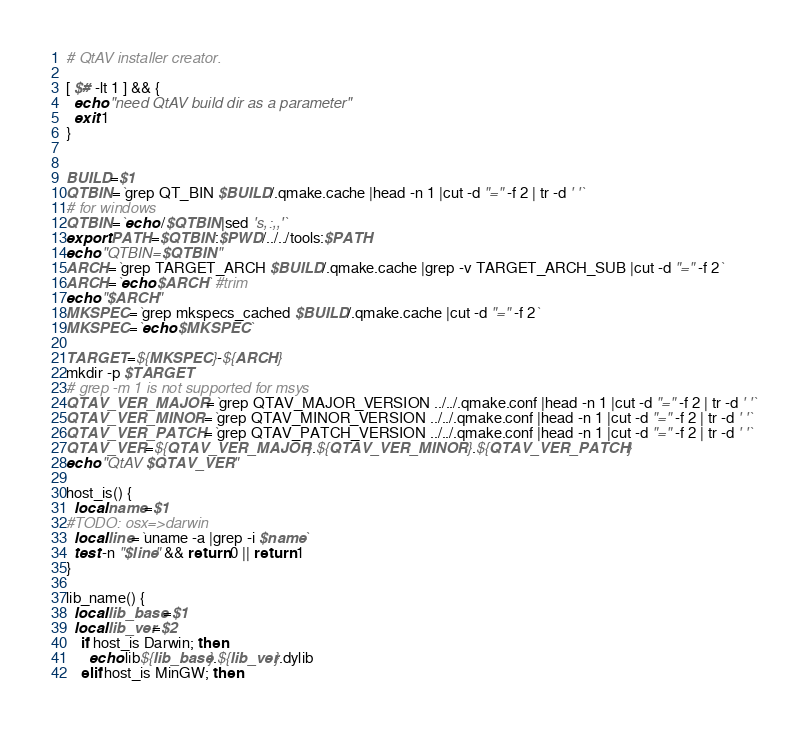Convert code to text. <code><loc_0><loc_0><loc_500><loc_500><_Bash_># QtAV installer creator.

[ $# -lt 1 ] && {
  echo "need QtAV build dir as a parameter"
  exit 1
}


BUILD=$1
QTBIN=`grep QT_BIN $BUILD/.qmake.cache |head -n 1 |cut -d "=" -f 2 | tr -d ' '`
# for windows
QTBIN=`echo /$QTBIN|sed 's,:,,'`
export PATH=$QTBIN:$PWD/../../tools:$PATH
echo "QTBIN=$QTBIN"
ARCH=`grep TARGET_ARCH $BUILD/.qmake.cache |grep -v TARGET_ARCH_SUB |cut -d "=" -f 2`
ARCH=`echo $ARCH` #trim
echo "$ARCH"
MKSPEC=`grep mkspecs_cached $BUILD/.qmake.cache |cut -d "=" -f 2`
MKSPEC=`echo $MKSPEC`

TARGET=${MKSPEC}-${ARCH}
mkdir -p $TARGET
# grep -m 1 is not supported for msys
QTAV_VER_MAJOR=`grep QTAV_MAJOR_VERSION ../../.qmake.conf |head -n 1 |cut -d "=" -f 2 | tr -d ' '`
QTAV_VER_MINOR=`grep QTAV_MINOR_VERSION ../../.qmake.conf |head -n 1 |cut -d "=" -f 2 | tr -d ' '`
QTAV_VER_PATCH=`grep QTAV_PATCH_VERSION ../../.qmake.conf |head -n 1 |cut -d "=" -f 2 | tr -d ' '`
QTAV_VER=${QTAV_VER_MAJOR}.${QTAV_VER_MINOR}.${QTAV_VER_PATCH}
echo "QtAV $QTAV_VER"

host_is() {
  local name=$1
#TODO: osx=>darwin
  local line=`uname -a |grep -i $name`
  test -n "$line" && return 0 || return 1
}

lib_name() {
  local lib_base=$1
  local lib_ver=$2
    if host_is Darwin; then
      echo lib${lib_base}.${lib_ver}.dylib
    elif host_is MinGW; then</code> 